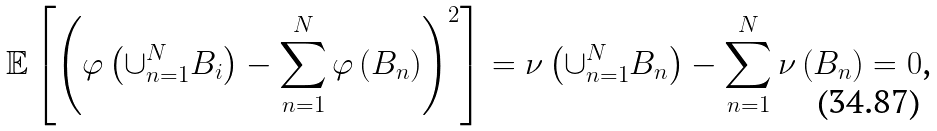<formula> <loc_0><loc_0><loc_500><loc_500>\mathbb { E } \left [ \left ( \varphi \left ( \cup _ { n = 1 } ^ { N } B _ { i } \right ) - \sum _ { n = 1 } ^ { N } \varphi \left ( B _ { n } \right ) \right ) ^ { 2 } \right ] = \nu \left ( \cup _ { n = 1 } ^ { N } B _ { n } \right ) - \sum _ { n = 1 } ^ { N } \nu \left ( B _ { n } \right ) = 0 \text {,}</formula> 